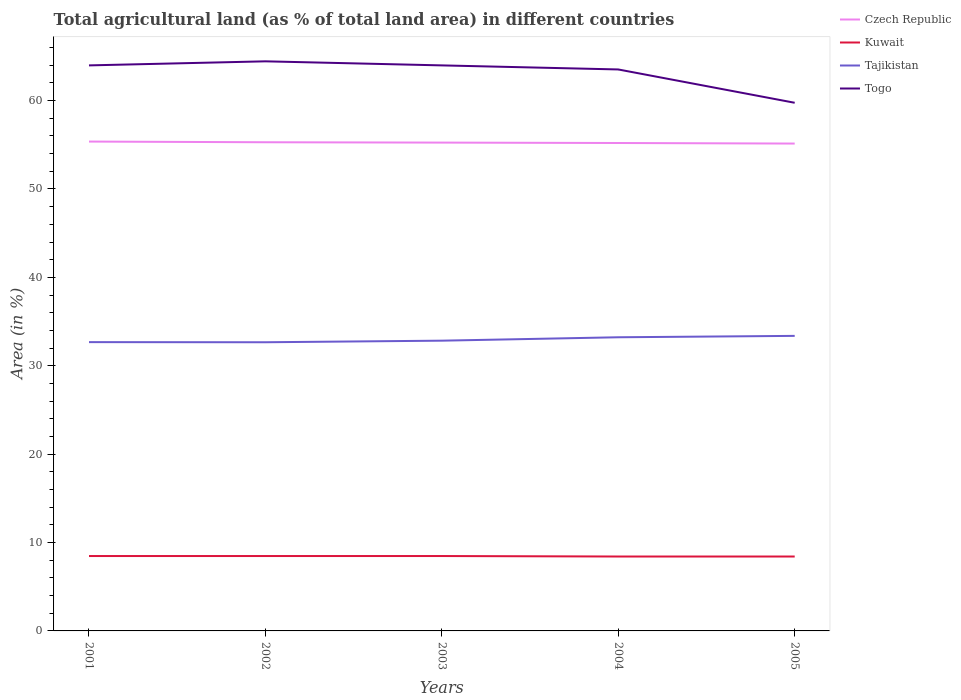Does the line corresponding to Togo intersect with the line corresponding to Czech Republic?
Provide a succinct answer. No. Is the number of lines equal to the number of legend labels?
Make the answer very short. Yes. Across all years, what is the maximum percentage of agricultural land in Tajikistan?
Ensure brevity in your answer.  32.66. What is the difference between the highest and the second highest percentage of agricultural land in Kuwait?
Your answer should be compact. 0.06. What is the difference between the highest and the lowest percentage of agricultural land in Togo?
Make the answer very short. 4. Is the percentage of agricultural land in Czech Republic strictly greater than the percentage of agricultural land in Togo over the years?
Your answer should be very brief. Yes. How many years are there in the graph?
Your response must be concise. 5. Are the values on the major ticks of Y-axis written in scientific E-notation?
Provide a short and direct response. No. Does the graph contain any zero values?
Give a very brief answer. No. Where does the legend appear in the graph?
Your answer should be very brief. Top right. How are the legend labels stacked?
Give a very brief answer. Vertical. What is the title of the graph?
Ensure brevity in your answer.  Total agricultural land (as % of total land area) in different countries. What is the label or title of the Y-axis?
Offer a terse response. Area (in %). What is the Area (in %) of Czech Republic in 2001?
Make the answer very short. 55.36. What is the Area (in %) of Kuwait in 2001?
Provide a succinct answer. 8.47. What is the Area (in %) of Tajikistan in 2001?
Keep it short and to the point. 32.67. What is the Area (in %) in Togo in 2001?
Provide a short and direct response. 63.98. What is the Area (in %) of Czech Republic in 2002?
Your answer should be very brief. 55.29. What is the Area (in %) of Kuwait in 2002?
Provide a short and direct response. 8.47. What is the Area (in %) of Tajikistan in 2002?
Keep it short and to the point. 32.66. What is the Area (in %) of Togo in 2002?
Provide a succinct answer. 64.44. What is the Area (in %) of Czech Republic in 2003?
Provide a succinct answer. 55.25. What is the Area (in %) in Kuwait in 2003?
Offer a terse response. 8.47. What is the Area (in %) of Tajikistan in 2003?
Offer a terse response. 32.84. What is the Area (in %) of Togo in 2003?
Your answer should be compact. 63.98. What is the Area (in %) of Czech Republic in 2004?
Offer a terse response. 55.2. What is the Area (in %) in Kuwait in 2004?
Keep it short and to the point. 8.42. What is the Area (in %) in Tajikistan in 2004?
Ensure brevity in your answer.  33.22. What is the Area (in %) in Togo in 2004?
Offer a terse response. 63.52. What is the Area (in %) in Czech Republic in 2005?
Your answer should be compact. 55.14. What is the Area (in %) in Kuwait in 2005?
Make the answer very short. 8.42. What is the Area (in %) in Tajikistan in 2005?
Give a very brief answer. 33.38. What is the Area (in %) of Togo in 2005?
Provide a succinct answer. 59.75. Across all years, what is the maximum Area (in %) in Czech Republic?
Make the answer very short. 55.36. Across all years, what is the maximum Area (in %) in Kuwait?
Provide a succinct answer. 8.47. Across all years, what is the maximum Area (in %) of Tajikistan?
Provide a short and direct response. 33.38. Across all years, what is the maximum Area (in %) of Togo?
Your answer should be compact. 64.44. Across all years, what is the minimum Area (in %) in Czech Republic?
Provide a succinct answer. 55.14. Across all years, what is the minimum Area (in %) in Kuwait?
Ensure brevity in your answer.  8.42. Across all years, what is the minimum Area (in %) in Tajikistan?
Your response must be concise. 32.66. Across all years, what is the minimum Area (in %) in Togo?
Your answer should be compact. 59.75. What is the total Area (in %) in Czech Republic in the graph?
Offer a very short reply. 276.24. What is the total Area (in %) in Kuwait in the graph?
Ensure brevity in your answer.  42.26. What is the total Area (in %) of Tajikistan in the graph?
Offer a very short reply. 164.78. What is the total Area (in %) of Togo in the graph?
Your response must be concise. 315.68. What is the difference between the Area (in %) of Czech Republic in 2001 and that in 2002?
Provide a short and direct response. 0.08. What is the difference between the Area (in %) of Kuwait in 2001 and that in 2002?
Your answer should be very brief. 0. What is the difference between the Area (in %) in Tajikistan in 2001 and that in 2002?
Your answer should be very brief. 0.01. What is the difference between the Area (in %) of Togo in 2001 and that in 2002?
Your answer should be very brief. -0.46. What is the difference between the Area (in %) in Czech Republic in 2001 and that in 2003?
Provide a short and direct response. 0.12. What is the difference between the Area (in %) of Kuwait in 2001 and that in 2003?
Your answer should be compact. 0. What is the difference between the Area (in %) in Tajikistan in 2001 and that in 2003?
Give a very brief answer. -0.16. What is the difference between the Area (in %) in Czech Republic in 2001 and that in 2004?
Your response must be concise. 0.16. What is the difference between the Area (in %) in Kuwait in 2001 and that in 2004?
Provide a succinct answer. 0.06. What is the difference between the Area (in %) in Tajikistan in 2001 and that in 2004?
Make the answer very short. -0.55. What is the difference between the Area (in %) in Togo in 2001 and that in 2004?
Give a very brief answer. 0.46. What is the difference between the Area (in %) in Czech Republic in 2001 and that in 2005?
Your answer should be very brief. 0.23. What is the difference between the Area (in %) in Kuwait in 2001 and that in 2005?
Provide a succinct answer. 0.06. What is the difference between the Area (in %) of Tajikistan in 2001 and that in 2005?
Your answer should be very brief. -0.71. What is the difference between the Area (in %) of Togo in 2001 and that in 2005?
Your response must be concise. 4.23. What is the difference between the Area (in %) of Czech Republic in 2002 and that in 2003?
Keep it short and to the point. 0.04. What is the difference between the Area (in %) of Tajikistan in 2002 and that in 2003?
Offer a terse response. -0.18. What is the difference between the Area (in %) in Togo in 2002 and that in 2003?
Your answer should be compact. 0.46. What is the difference between the Area (in %) in Czech Republic in 2002 and that in 2004?
Provide a short and direct response. 0.08. What is the difference between the Area (in %) of Kuwait in 2002 and that in 2004?
Keep it short and to the point. 0.06. What is the difference between the Area (in %) of Tajikistan in 2002 and that in 2004?
Your answer should be compact. -0.56. What is the difference between the Area (in %) in Togo in 2002 and that in 2004?
Your answer should be very brief. 0.92. What is the difference between the Area (in %) of Czech Republic in 2002 and that in 2005?
Make the answer very short. 0.15. What is the difference between the Area (in %) in Kuwait in 2002 and that in 2005?
Make the answer very short. 0.06. What is the difference between the Area (in %) of Tajikistan in 2002 and that in 2005?
Your answer should be compact. -0.72. What is the difference between the Area (in %) in Togo in 2002 and that in 2005?
Ensure brevity in your answer.  4.69. What is the difference between the Area (in %) of Czech Republic in 2003 and that in 2004?
Ensure brevity in your answer.  0.04. What is the difference between the Area (in %) of Kuwait in 2003 and that in 2004?
Keep it short and to the point. 0.06. What is the difference between the Area (in %) of Tajikistan in 2003 and that in 2004?
Your answer should be very brief. -0.39. What is the difference between the Area (in %) of Togo in 2003 and that in 2004?
Give a very brief answer. 0.46. What is the difference between the Area (in %) in Czech Republic in 2003 and that in 2005?
Provide a succinct answer. 0.11. What is the difference between the Area (in %) in Kuwait in 2003 and that in 2005?
Ensure brevity in your answer.  0.06. What is the difference between the Area (in %) of Tajikistan in 2003 and that in 2005?
Offer a terse response. -0.54. What is the difference between the Area (in %) in Togo in 2003 and that in 2005?
Offer a very short reply. 4.23. What is the difference between the Area (in %) in Czech Republic in 2004 and that in 2005?
Ensure brevity in your answer.  0.06. What is the difference between the Area (in %) in Kuwait in 2004 and that in 2005?
Provide a short and direct response. 0. What is the difference between the Area (in %) in Tajikistan in 2004 and that in 2005?
Ensure brevity in your answer.  -0.16. What is the difference between the Area (in %) of Togo in 2004 and that in 2005?
Offer a very short reply. 3.77. What is the difference between the Area (in %) of Czech Republic in 2001 and the Area (in %) of Kuwait in 2002?
Offer a terse response. 46.89. What is the difference between the Area (in %) in Czech Republic in 2001 and the Area (in %) in Tajikistan in 2002?
Offer a terse response. 22.7. What is the difference between the Area (in %) in Czech Republic in 2001 and the Area (in %) in Togo in 2002?
Provide a succinct answer. -9.08. What is the difference between the Area (in %) of Kuwait in 2001 and the Area (in %) of Tajikistan in 2002?
Keep it short and to the point. -24.19. What is the difference between the Area (in %) in Kuwait in 2001 and the Area (in %) in Togo in 2002?
Give a very brief answer. -55.97. What is the difference between the Area (in %) in Tajikistan in 2001 and the Area (in %) in Togo in 2002?
Your response must be concise. -31.77. What is the difference between the Area (in %) in Czech Republic in 2001 and the Area (in %) in Kuwait in 2003?
Provide a short and direct response. 46.89. What is the difference between the Area (in %) in Czech Republic in 2001 and the Area (in %) in Tajikistan in 2003?
Offer a very short reply. 22.53. What is the difference between the Area (in %) of Czech Republic in 2001 and the Area (in %) of Togo in 2003?
Keep it short and to the point. -8.62. What is the difference between the Area (in %) of Kuwait in 2001 and the Area (in %) of Tajikistan in 2003?
Your answer should be very brief. -24.36. What is the difference between the Area (in %) in Kuwait in 2001 and the Area (in %) in Togo in 2003?
Your answer should be compact. -55.51. What is the difference between the Area (in %) of Tajikistan in 2001 and the Area (in %) of Togo in 2003?
Provide a short and direct response. -31.31. What is the difference between the Area (in %) of Czech Republic in 2001 and the Area (in %) of Kuwait in 2004?
Ensure brevity in your answer.  46.95. What is the difference between the Area (in %) in Czech Republic in 2001 and the Area (in %) in Tajikistan in 2004?
Give a very brief answer. 22.14. What is the difference between the Area (in %) of Czech Republic in 2001 and the Area (in %) of Togo in 2004?
Your answer should be compact. -8.16. What is the difference between the Area (in %) of Kuwait in 2001 and the Area (in %) of Tajikistan in 2004?
Keep it short and to the point. -24.75. What is the difference between the Area (in %) of Kuwait in 2001 and the Area (in %) of Togo in 2004?
Your answer should be very brief. -55.05. What is the difference between the Area (in %) of Tajikistan in 2001 and the Area (in %) of Togo in 2004?
Ensure brevity in your answer.  -30.85. What is the difference between the Area (in %) in Czech Republic in 2001 and the Area (in %) in Kuwait in 2005?
Offer a very short reply. 46.95. What is the difference between the Area (in %) of Czech Republic in 2001 and the Area (in %) of Tajikistan in 2005?
Offer a very short reply. 21.98. What is the difference between the Area (in %) of Czech Republic in 2001 and the Area (in %) of Togo in 2005?
Offer a very short reply. -4.39. What is the difference between the Area (in %) in Kuwait in 2001 and the Area (in %) in Tajikistan in 2005?
Give a very brief answer. -24.91. What is the difference between the Area (in %) of Kuwait in 2001 and the Area (in %) of Togo in 2005?
Offer a very short reply. -51.28. What is the difference between the Area (in %) of Tajikistan in 2001 and the Area (in %) of Togo in 2005?
Your answer should be compact. -27.08. What is the difference between the Area (in %) in Czech Republic in 2002 and the Area (in %) in Kuwait in 2003?
Your answer should be very brief. 46.81. What is the difference between the Area (in %) of Czech Republic in 2002 and the Area (in %) of Tajikistan in 2003?
Your answer should be very brief. 22.45. What is the difference between the Area (in %) in Czech Republic in 2002 and the Area (in %) in Togo in 2003?
Provide a succinct answer. -8.7. What is the difference between the Area (in %) in Kuwait in 2002 and the Area (in %) in Tajikistan in 2003?
Provide a succinct answer. -24.36. What is the difference between the Area (in %) of Kuwait in 2002 and the Area (in %) of Togo in 2003?
Provide a short and direct response. -55.51. What is the difference between the Area (in %) in Tajikistan in 2002 and the Area (in %) in Togo in 2003?
Make the answer very short. -31.32. What is the difference between the Area (in %) in Czech Republic in 2002 and the Area (in %) in Kuwait in 2004?
Ensure brevity in your answer.  46.87. What is the difference between the Area (in %) of Czech Republic in 2002 and the Area (in %) of Tajikistan in 2004?
Provide a succinct answer. 22.06. What is the difference between the Area (in %) of Czech Republic in 2002 and the Area (in %) of Togo in 2004?
Keep it short and to the point. -8.24. What is the difference between the Area (in %) in Kuwait in 2002 and the Area (in %) in Tajikistan in 2004?
Your answer should be very brief. -24.75. What is the difference between the Area (in %) in Kuwait in 2002 and the Area (in %) in Togo in 2004?
Your answer should be compact. -55.05. What is the difference between the Area (in %) in Tajikistan in 2002 and the Area (in %) in Togo in 2004?
Ensure brevity in your answer.  -30.86. What is the difference between the Area (in %) of Czech Republic in 2002 and the Area (in %) of Kuwait in 2005?
Provide a succinct answer. 46.87. What is the difference between the Area (in %) of Czech Republic in 2002 and the Area (in %) of Tajikistan in 2005?
Keep it short and to the point. 21.91. What is the difference between the Area (in %) of Czech Republic in 2002 and the Area (in %) of Togo in 2005?
Your response must be concise. -4.47. What is the difference between the Area (in %) of Kuwait in 2002 and the Area (in %) of Tajikistan in 2005?
Offer a very short reply. -24.91. What is the difference between the Area (in %) in Kuwait in 2002 and the Area (in %) in Togo in 2005?
Provide a short and direct response. -51.28. What is the difference between the Area (in %) of Tajikistan in 2002 and the Area (in %) of Togo in 2005?
Your response must be concise. -27.09. What is the difference between the Area (in %) of Czech Republic in 2003 and the Area (in %) of Kuwait in 2004?
Your answer should be compact. 46.83. What is the difference between the Area (in %) of Czech Republic in 2003 and the Area (in %) of Tajikistan in 2004?
Offer a terse response. 22.02. What is the difference between the Area (in %) in Czech Republic in 2003 and the Area (in %) in Togo in 2004?
Ensure brevity in your answer.  -8.27. What is the difference between the Area (in %) of Kuwait in 2003 and the Area (in %) of Tajikistan in 2004?
Your answer should be compact. -24.75. What is the difference between the Area (in %) of Kuwait in 2003 and the Area (in %) of Togo in 2004?
Your answer should be very brief. -55.05. What is the difference between the Area (in %) of Tajikistan in 2003 and the Area (in %) of Togo in 2004?
Keep it short and to the point. -30.68. What is the difference between the Area (in %) in Czech Republic in 2003 and the Area (in %) in Kuwait in 2005?
Give a very brief answer. 46.83. What is the difference between the Area (in %) of Czech Republic in 2003 and the Area (in %) of Tajikistan in 2005?
Ensure brevity in your answer.  21.87. What is the difference between the Area (in %) in Czech Republic in 2003 and the Area (in %) in Togo in 2005?
Provide a short and direct response. -4.51. What is the difference between the Area (in %) in Kuwait in 2003 and the Area (in %) in Tajikistan in 2005?
Ensure brevity in your answer.  -24.91. What is the difference between the Area (in %) in Kuwait in 2003 and the Area (in %) in Togo in 2005?
Make the answer very short. -51.28. What is the difference between the Area (in %) of Tajikistan in 2003 and the Area (in %) of Togo in 2005?
Ensure brevity in your answer.  -26.92. What is the difference between the Area (in %) in Czech Republic in 2004 and the Area (in %) in Kuwait in 2005?
Make the answer very short. 46.79. What is the difference between the Area (in %) in Czech Republic in 2004 and the Area (in %) in Tajikistan in 2005?
Ensure brevity in your answer.  21.82. What is the difference between the Area (in %) in Czech Republic in 2004 and the Area (in %) in Togo in 2005?
Ensure brevity in your answer.  -4.55. What is the difference between the Area (in %) of Kuwait in 2004 and the Area (in %) of Tajikistan in 2005?
Offer a terse response. -24.96. What is the difference between the Area (in %) of Kuwait in 2004 and the Area (in %) of Togo in 2005?
Make the answer very short. -51.34. What is the difference between the Area (in %) in Tajikistan in 2004 and the Area (in %) in Togo in 2005?
Your response must be concise. -26.53. What is the average Area (in %) in Czech Republic per year?
Your answer should be compact. 55.25. What is the average Area (in %) of Kuwait per year?
Provide a short and direct response. 8.45. What is the average Area (in %) in Tajikistan per year?
Your answer should be compact. 32.96. What is the average Area (in %) of Togo per year?
Keep it short and to the point. 63.14. In the year 2001, what is the difference between the Area (in %) of Czech Republic and Area (in %) of Kuwait?
Your answer should be compact. 46.89. In the year 2001, what is the difference between the Area (in %) in Czech Republic and Area (in %) in Tajikistan?
Offer a terse response. 22.69. In the year 2001, what is the difference between the Area (in %) in Czech Republic and Area (in %) in Togo?
Your response must be concise. -8.62. In the year 2001, what is the difference between the Area (in %) in Kuwait and Area (in %) in Tajikistan?
Your answer should be compact. -24.2. In the year 2001, what is the difference between the Area (in %) of Kuwait and Area (in %) of Togo?
Your response must be concise. -55.51. In the year 2001, what is the difference between the Area (in %) of Tajikistan and Area (in %) of Togo?
Provide a succinct answer. -31.31. In the year 2002, what is the difference between the Area (in %) in Czech Republic and Area (in %) in Kuwait?
Keep it short and to the point. 46.81. In the year 2002, what is the difference between the Area (in %) of Czech Republic and Area (in %) of Tajikistan?
Ensure brevity in your answer.  22.63. In the year 2002, what is the difference between the Area (in %) of Czech Republic and Area (in %) of Togo?
Offer a terse response. -9.16. In the year 2002, what is the difference between the Area (in %) in Kuwait and Area (in %) in Tajikistan?
Keep it short and to the point. -24.19. In the year 2002, what is the difference between the Area (in %) of Kuwait and Area (in %) of Togo?
Your answer should be very brief. -55.97. In the year 2002, what is the difference between the Area (in %) in Tajikistan and Area (in %) in Togo?
Your response must be concise. -31.78. In the year 2003, what is the difference between the Area (in %) of Czech Republic and Area (in %) of Kuwait?
Offer a terse response. 46.77. In the year 2003, what is the difference between the Area (in %) in Czech Republic and Area (in %) in Tajikistan?
Provide a short and direct response. 22.41. In the year 2003, what is the difference between the Area (in %) of Czech Republic and Area (in %) of Togo?
Offer a terse response. -8.73. In the year 2003, what is the difference between the Area (in %) in Kuwait and Area (in %) in Tajikistan?
Your response must be concise. -24.36. In the year 2003, what is the difference between the Area (in %) in Kuwait and Area (in %) in Togo?
Offer a terse response. -55.51. In the year 2003, what is the difference between the Area (in %) in Tajikistan and Area (in %) in Togo?
Keep it short and to the point. -31.14. In the year 2004, what is the difference between the Area (in %) of Czech Republic and Area (in %) of Kuwait?
Provide a short and direct response. 46.79. In the year 2004, what is the difference between the Area (in %) in Czech Republic and Area (in %) in Tajikistan?
Your answer should be very brief. 21.98. In the year 2004, what is the difference between the Area (in %) of Czech Republic and Area (in %) of Togo?
Offer a very short reply. -8.32. In the year 2004, what is the difference between the Area (in %) in Kuwait and Area (in %) in Tajikistan?
Provide a succinct answer. -24.81. In the year 2004, what is the difference between the Area (in %) of Kuwait and Area (in %) of Togo?
Provide a short and direct response. -55.11. In the year 2004, what is the difference between the Area (in %) in Tajikistan and Area (in %) in Togo?
Provide a succinct answer. -30.3. In the year 2005, what is the difference between the Area (in %) in Czech Republic and Area (in %) in Kuwait?
Offer a terse response. 46.72. In the year 2005, what is the difference between the Area (in %) in Czech Republic and Area (in %) in Tajikistan?
Provide a short and direct response. 21.76. In the year 2005, what is the difference between the Area (in %) in Czech Republic and Area (in %) in Togo?
Provide a short and direct response. -4.62. In the year 2005, what is the difference between the Area (in %) of Kuwait and Area (in %) of Tajikistan?
Keep it short and to the point. -24.96. In the year 2005, what is the difference between the Area (in %) of Kuwait and Area (in %) of Togo?
Make the answer very short. -51.34. In the year 2005, what is the difference between the Area (in %) of Tajikistan and Area (in %) of Togo?
Ensure brevity in your answer.  -26.37. What is the ratio of the Area (in %) in Czech Republic in 2001 to that in 2002?
Give a very brief answer. 1. What is the ratio of the Area (in %) of Kuwait in 2001 to that in 2002?
Keep it short and to the point. 1. What is the ratio of the Area (in %) of Tajikistan in 2001 to that in 2002?
Give a very brief answer. 1. What is the ratio of the Area (in %) of Czech Republic in 2001 to that in 2003?
Your answer should be very brief. 1. What is the ratio of the Area (in %) of Kuwait in 2001 to that in 2003?
Provide a succinct answer. 1. What is the ratio of the Area (in %) of Tajikistan in 2001 to that in 2003?
Provide a short and direct response. 0.99. What is the ratio of the Area (in %) in Togo in 2001 to that in 2003?
Your response must be concise. 1. What is the ratio of the Area (in %) in Czech Republic in 2001 to that in 2004?
Keep it short and to the point. 1. What is the ratio of the Area (in %) of Kuwait in 2001 to that in 2004?
Your answer should be compact. 1.01. What is the ratio of the Area (in %) in Tajikistan in 2001 to that in 2004?
Offer a terse response. 0.98. What is the ratio of the Area (in %) in Kuwait in 2001 to that in 2005?
Offer a terse response. 1.01. What is the ratio of the Area (in %) of Tajikistan in 2001 to that in 2005?
Offer a very short reply. 0.98. What is the ratio of the Area (in %) of Togo in 2001 to that in 2005?
Provide a succinct answer. 1.07. What is the ratio of the Area (in %) of Czech Republic in 2002 to that in 2003?
Your answer should be very brief. 1. What is the ratio of the Area (in %) of Kuwait in 2002 to that in 2004?
Your answer should be compact. 1.01. What is the ratio of the Area (in %) of Togo in 2002 to that in 2004?
Provide a short and direct response. 1.01. What is the ratio of the Area (in %) of Kuwait in 2002 to that in 2005?
Your answer should be very brief. 1.01. What is the ratio of the Area (in %) of Tajikistan in 2002 to that in 2005?
Keep it short and to the point. 0.98. What is the ratio of the Area (in %) in Togo in 2002 to that in 2005?
Your answer should be compact. 1.08. What is the ratio of the Area (in %) in Czech Republic in 2003 to that in 2004?
Ensure brevity in your answer.  1. What is the ratio of the Area (in %) in Tajikistan in 2003 to that in 2004?
Offer a terse response. 0.99. What is the ratio of the Area (in %) of Togo in 2003 to that in 2004?
Your response must be concise. 1.01. What is the ratio of the Area (in %) of Czech Republic in 2003 to that in 2005?
Give a very brief answer. 1. What is the ratio of the Area (in %) of Tajikistan in 2003 to that in 2005?
Keep it short and to the point. 0.98. What is the ratio of the Area (in %) of Togo in 2003 to that in 2005?
Provide a succinct answer. 1.07. What is the ratio of the Area (in %) of Tajikistan in 2004 to that in 2005?
Make the answer very short. 1. What is the ratio of the Area (in %) in Togo in 2004 to that in 2005?
Keep it short and to the point. 1.06. What is the difference between the highest and the second highest Area (in %) of Czech Republic?
Keep it short and to the point. 0.08. What is the difference between the highest and the second highest Area (in %) in Tajikistan?
Give a very brief answer. 0.16. What is the difference between the highest and the second highest Area (in %) in Togo?
Offer a terse response. 0.46. What is the difference between the highest and the lowest Area (in %) of Czech Republic?
Ensure brevity in your answer.  0.23. What is the difference between the highest and the lowest Area (in %) of Kuwait?
Offer a terse response. 0.06. What is the difference between the highest and the lowest Area (in %) of Tajikistan?
Your answer should be very brief. 0.72. What is the difference between the highest and the lowest Area (in %) of Togo?
Provide a succinct answer. 4.69. 